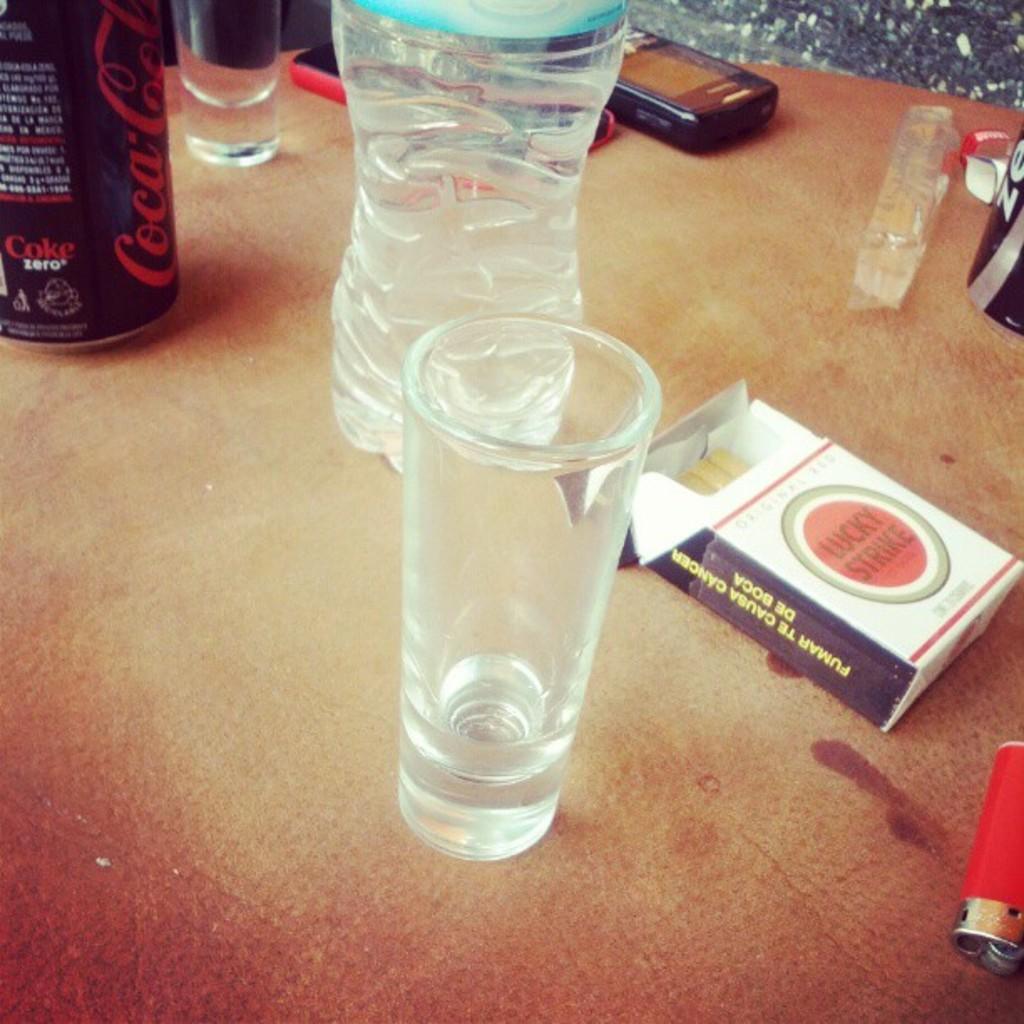In one or two sentences, can you explain what this image depicts? In this picture, there is a table. On the table, there are glasses, bottle, can, cigarette box, lighter and some other objects are placed. 